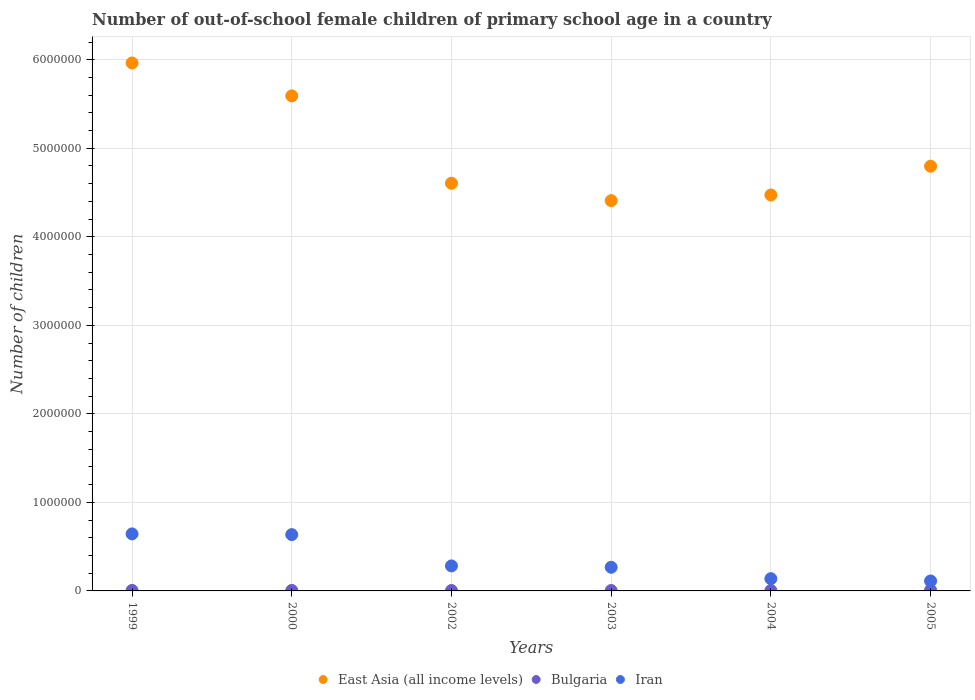How many different coloured dotlines are there?
Your response must be concise. 3. What is the number of out-of-school female children in East Asia (all income levels) in 2005?
Ensure brevity in your answer.  4.80e+06. Across all years, what is the maximum number of out-of-school female children in East Asia (all income levels)?
Offer a terse response. 5.96e+06. Across all years, what is the minimum number of out-of-school female children in Iran?
Your response must be concise. 1.12e+05. In which year was the number of out-of-school female children in Bulgaria maximum?
Make the answer very short. 2005. In which year was the number of out-of-school female children in Bulgaria minimum?
Your response must be concise. 2003. What is the total number of out-of-school female children in Iran in the graph?
Keep it short and to the point. 2.08e+06. What is the difference between the number of out-of-school female children in Iran in 2000 and that in 2005?
Your answer should be very brief. 5.24e+05. What is the difference between the number of out-of-school female children in East Asia (all income levels) in 2004 and the number of out-of-school female children in Bulgaria in 2005?
Your answer should be very brief. 4.46e+06. What is the average number of out-of-school female children in East Asia (all income levels) per year?
Keep it short and to the point. 4.97e+06. In the year 2004, what is the difference between the number of out-of-school female children in Bulgaria and number of out-of-school female children in Iran?
Provide a short and direct response. -1.34e+05. What is the ratio of the number of out-of-school female children in East Asia (all income levels) in 2000 to that in 2004?
Provide a short and direct response. 1.25. Is the difference between the number of out-of-school female children in Bulgaria in 1999 and 2003 greater than the difference between the number of out-of-school female children in Iran in 1999 and 2003?
Ensure brevity in your answer.  No. What is the difference between the highest and the second highest number of out-of-school female children in East Asia (all income levels)?
Your response must be concise. 3.72e+05. What is the difference between the highest and the lowest number of out-of-school female children in East Asia (all income levels)?
Your answer should be compact. 1.56e+06. In how many years, is the number of out-of-school female children in Bulgaria greater than the average number of out-of-school female children in Bulgaria taken over all years?
Make the answer very short. 1. Is it the case that in every year, the sum of the number of out-of-school female children in Iran and number of out-of-school female children in Bulgaria  is greater than the number of out-of-school female children in East Asia (all income levels)?
Your answer should be compact. No. Is the number of out-of-school female children in East Asia (all income levels) strictly less than the number of out-of-school female children in Bulgaria over the years?
Your answer should be compact. No. How many dotlines are there?
Offer a very short reply. 3. How many years are there in the graph?
Make the answer very short. 6. Does the graph contain grids?
Keep it short and to the point. Yes. Where does the legend appear in the graph?
Your answer should be compact. Bottom center. How many legend labels are there?
Your answer should be very brief. 3. How are the legend labels stacked?
Keep it short and to the point. Horizontal. What is the title of the graph?
Your response must be concise. Number of out-of-school female children of primary school age in a country. What is the label or title of the X-axis?
Keep it short and to the point. Years. What is the label or title of the Y-axis?
Your answer should be very brief. Number of children. What is the Number of children in East Asia (all income levels) in 1999?
Your answer should be compact. 5.96e+06. What is the Number of children in Bulgaria in 1999?
Provide a succinct answer. 5332. What is the Number of children of Iran in 1999?
Offer a very short reply. 6.44e+05. What is the Number of children of East Asia (all income levels) in 2000?
Give a very brief answer. 5.59e+06. What is the Number of children in Bulgaria in 2000?
Provide a succinct answer. 5362. What is the Number of children of Iran in 2000?
Your answer should be compact. 6.36e+05. What is the Number of children of East Asia (all income levels) in 2002?
Offer a terse response. 4.61e+06. What is the Number of children of Bulgaria in 2002?
Provide a short and direct response. 4759. What is the Number of children in Iran in 2002?
Offer a very short reply. 2.83e+05. What is the Number of children of East Asia (all income levels) in 2003?
Your response must be concise. 4.41e+06. What is the Number of children of Bulgaria in 2003?
Your answer should be very brief. 4347. What is the Number of children in Iran in 2003?
Provide a short and direct response. 2.67e+05. What is the Number of children in East Asia (all income levels) in 2004?
Your response must be concise. 4.47e+06. What is the Number of children in Bulgaria in 2004?
Keep it short and to the point. 4721. What is the Number of children of Iran in 2004?
Your response must be concise. 1.38e+05. What is the Number of children in East Asia (all income levels) in 2005?
Offer a terse response. 4.80e+06. What is the Number of children of Bulgaria in 2005?
Your response must be concise. 8739. What is the Number of children of Iran in 2005?
Your response must be concise. 1.12e+05. Across all years, what is the maximum Number of children in East Asia (all income levels)?
Your response must be concise. 5.96e+06. Across all years, what is the maximum Number of children of Bulgaria?
Offer a very short reply. 8739. Across all years, what is the maximum Number of children of Iran?
Provide a short and direct response. 6.44e+05. Across all years, what is the minimum Number of children of East Asia (all income levels)?
Give a very brief answer. 4.41e+06. Across all years, what is the minimum Number of children of Bulgaria?
Your response must be concise. 4347. Across all years, what is the minimum Number of children in Iran?
Offer a terse response. 1.12e+05. What is the total Number of children in East Asia (all income levels) in the graph?
Give a very brief answer. 2.98e+07. What is the total Number of children in Bulgaria in the graph?
Provide a short and direct response. 3.33e+04. What is the total Number of children in Iran in the graph?
Ensure brevity in your answer.  2.08e+06. What is the difference between the Number of children in East Asia (all income levels) in 1999 and that in 2000?
Your response must be concise. 3.72e+05. What is the difference between the Number of children of Bulgaria in 1999 and that in 2000?
Offer a very short reply. -30. What is the difference between the Number of children of Iran in 1999 and that in 2000?
Your answer should be compact. 8106. What is the difference between the Number of children in East Asia (all income levels) in 1999 and that in 2002?
Ensure brevity in your answer.  1.36e+06. What is the difference between the Number of children in Bulgaria in 1999 and that in 2002?
Provide a short and direct response. 573. What is the difference between the Number of children in Iran in 1999 and that in 2002?
Ensure brevity in your answer.  3.62e+05. What is the difference between the Number of children in East Asia (all income levels) in 1999 and that in 2003?
Keep it short and to the point. 1.56e+06. What is the difference between the Number of children of Bulgaria in 1999 and that in 2003?
Make the answer very short. 985. What is the difference between the Number of children in Iran in 1999 and that in 2003?
Make the answer very short. 3.77e+05. What is the difference between the Number of children of East Asia (all income levels) in 1999 and that in 2004?
Make the answer very short. 1.49e+06. What is the difference between the Number of children of Bulgaria in 1999 and that in 2004?
Your response must be concise. 611. What is the difference between the Number of children in Iran in 1999 and that in 2004?
Provide a short and direct response. 5.06e+05. What is the difference between the Number of children of East Asia (all income levels) in 1999 and that in 2005?
Offer a terse response. 1.17e+06. What is the difference between the Number of children of Bulgaria in 1999 and that in 2005?
Keep it short and to the point. -3407. What is the difference between the Number of children of Iran in 1999 and that in 2005?
Your answer should be compact. 5.32e+05. What is the difference between the Number of children of East Asia (all income levels) in 2000 and that in 2002?
Provide a short and direct response. 9.87e+05. What is the difference between the Number of children of Bulgaria in 2000 and that in 2002?
Give a very brief answer. 603. What is the difference between the Number of children in Iran in 2000 and that in 2002?
Your response must be concise. 3.53e+05. What is the difference between the Number of children in East Asia (all income levels) in 2000 and that in 2003?
Provide a succinct answer. 1.18e+06. What is the difference between the Number of children of Bulgaria in 2000 and that in 2003?
Offer a very short reply. 1015. What is the difference between the Number of children of Iran in 2000 and that in 2003?
Your response must be concise. 3.69e+05. What is the difference between the Number of children in East Asia (all income levels) in 2000 and that in 2004?
Give a very brief answer. 1.12e+06. What is the difference between the Number of children of Bulgaria in 2000 and that in 2004?
Keep it short and to the point. 641. What is the difference between the Number of children in Iran in 2000 and that in 2004?
Your answer should be compact. 4.98e+05. What is the difference between the Number of children of East Asia (all income levels) in 2000 and that in 2005?
Make the answer very short. 7.94e+05. What is the difference between the Number of children in Bulgaria in 2000 and that in 2005?
Make the answer very short. -3377. What is the difference between the Number of children of Iran in 2000 and that in 2005?
Offer a terse response. 5.24e+05. What is the difference between the Number of children in East Asia (all income levels) in 2002 and that in 2003?
Keep it short and to the point. 1.97e+05. What is the difference between the Number of children in Bulgaria in 2002 and that in 2003?
Your response must be concise. 412. What is the difference between the Number of children in Iran in 2002 and that in 2003?
Your response must be concise. 1.54e+04. What is the difference between the Number of children of East Asia (all income levels) in 2002 and that in 2004?
Keep it short and to the point. 1.33e+05. What is the difference between the Number of children of Iran in 2002 and that in 2004?
Offer a terse response. 1.44e+05. What is the difference between the Number of children in East Asia (all income levels) in 2002 and that in 2005?
Ensure brevity in your answer.  -1.92e+05. What is the difference between the Number of children of Bulgaria in 2002 and that in 2005?
Ensure brevity in your answer.  -3980. What is the difference between the Number of children in Iran in 2002 and that in 2005?
Your answer should be compact. 1.70e+05. What is the difference between the Number of children of East Asia (all income levels) in 2003 and that in 2004?
Your answer should be very brief. -6.36e+04. What is the difference between the Number of children of Bulgaria in 2003 and that in 2004?
Your answer should be very brief. -374. What is the difference between the Number of children in Iran in 2003 and that in 2004?
Provide a short and direct response. 1.29e+05. What is the difference between the Number of children in East Asia (all income levels) in 2003 and that in 2005?
Offer a very short reply. -3.89e+05. What is the difference between the Number of children of Bulgaria in 2003 and that in 2005?
Offer a very short reply. -4392. What is the difference between the Number of children of Iran in 2003 and that in 2005?
Keep it short and to the point. 1.55e+05. What is the difference between the Number of children in East Asia (all income levels) in 2004 and that in 2005?
Ensure brevity in your answer.  -3.25e+05. What is the difference between the Number of children in Bulgaria in 2004 and that in 2005?
Offer a very short reply. -4018. What is the difference between the Number of children of Iran in 2004 and that in 2005?
Give a very brief answer. 2.59e+04. What is the difference between the Number of children of East Asia (all income levels) in 1999 and the Number of children of Bulgaria in 2000?
Provide a succinct answer. 5.96e+06. What is the difference between the Number of children in East Asia (all income levels) in 1999 and the Number of children in Iran in 2000?
Your response must be concise. 5.33e+06. What is the difference between the Number of children of Bulgaria in 1999 and the Number of children of Iran in 2000?
Provide a succinct answer. -6.31e+05. What is the difference between the Number of children of East Asia (all income levels) in 1999 and the Number of children of Bulgaria in 2002?
Offer a very short reply. 5.96e+06. What is the difference between the Number of children in East Asia (all income levels) in 1999 and the Number of children in Iran in 2002?
Your answer should be compact. 5.68e+06. What is the difference between the Number of children in Bulgaria in 1999 and the Number of children in Iran in 2002?
Ensure brevity in your answer.  -2.77e+05. What is the difference between the Number of children in East Asia (all income levels) in 1999 and the Number of children in Bulgaria in 2003?
Offer a very short reply. 5.96e+06. What is the difference between the Number of children in East Asia (all income levels) in 1999 and the Number of children in Iran in 2003?
Your answer should be very brief. 5.70e+06. What is the difference between the Number of children of Bulgaria in 1999 and the Number of children of Iran in 2003?
Give a very brief answer. -2.62e+05. What is the difference between the Number of children in East Asia (all income levels) in 1999 and the Number of children in Bulgaria in 2004?
Give a very brief answer. 5.96e+06. What is the difference between the Number of children in East Asia (all income levels) in 1999 and the Number of children in Iran in 2004?
Your answer should be compact. 5.83e+06. What is the difference between the Number of children of Bulgaria in 1999 and the Number of children of Iran in 2004?
Your response must be concise. -1.33e+05. What is the difference between the Number of children of East Asia (all income levels) in 1999 and the Number of children of Bulgaria in 2005?
Offer a terse response. 5.95e+06. What is the difference between the Number of children of East Asia (all income levels) in 1999 and the Number of children of Iran in 2005?
Provide a succinct answer. 5.85e+06. What is the difference between the Number of children in Bulgaria in 1999 and the Number of children in Iran in 2005?
Provide a succinct answer. -1.07e+05. What is the difference between the Number of children in East Asia (all income levels) in 2000 and the Number of children in Bulgaria in 2002?
Your answer should be very brief. 5.59e+06. What is the difference between the Number of children of East Asia (all income levels) in 2000 and the Number of children of Iran in 2002?
Make the answer very short. 5.31e+06. What is the difference between the Number of children in Bulgaria in 2000 and the Number of children in Iran in 2002?
Your answer should be compact. -2.77e+05. What is the difference between the Number of children of East Asia (all income levels) in 2000 and the Number of children of Bulgaria in 2003?
Provide a succinct answer. 5.59e+06. What is the difference between the Number of children in East Asia (all income levels) in 2000 and the Number of children in Iran in 2003?
Your response must be concise. 5.32e+06. What is the difference between the Number of children in Bulgaria in 2000 and the Number of children in Iran in 2003?
Your answer should be very brief. -2.62e+05. What is the difference between the Number of children in East Asia (all income levels) in 2000 and the Number of children in Bulgaria in 2004?
Provide a succinct answer. 5.59e+06. What is the difference between the Number of children in East Asia (all income levels) in 2000 and the Number of children in Iran in 2004?
Make the answer very short. 5.45e+06. What is the difference between the Number of children in Bulgaria in 2000 and the Number of children in Iran in 2004?
Make the answer very short. -1.33e+05. What is the difference between the Number of children in East Asia (all income levels) in 2000 and the Number of children in Bulgaria in 2005?
Your answer should be compact. 5.58e+06. What is the difference between the Number of children in East Asia (all income levels) in 2000 and the Number of children in Iran in 2005?
Give a very brief answer. 5.48e+06. What is the difference between the Number of children in Bulgaria in 2000 and the Number of children in Iran in 2005?
Provide a succinct answer. -1.07e+05. What is the difference between the Number of children of East Asia (all income levels) in 2002 and the Number of children of Bulgaria in 2003?
Make the answer very short. 4.60e+06. What is the difference between the Number of children in East Asia (all income levels) in 2002 and the Number of children in Iran in 2003?
Offer a very short reply. 4.34e+06. What is the difference between the Number of children in Bulgaria in 2002 and the Number of children in Iran in 2003?
Keep it short and to the point. -2.62e+05. What is the difference between the Number of children in East Asia (all income levels) in 2002 and the Number of children in Bulgaria in 2004?
Keep it short and to the point. 4.60e+06. What is the difference between the Number of children of East Asia (all income levels) in 2002 and the Number of children of Iran in 2004?
Ensure brevity in your answer.  4.47e+06. What is the difference between the Number of children of Bulgaria in 2002 and the Number of children of Iran in 2004?
Offer a very short reply. -1.34e+05. What is the difference between the Number of children of East Asia (all income levels) in 2002 and the Number of children of Bulgaria in 2005?
Keep it short and to the point. 4.60e+06. What is the difference between the Number of children in East Asia (all income levels) in 2002 and the Number of children in Iran in 2005?
Keep it short and to the point. 4.49e+06. What is the difference between the Number of children of Bulgaria in 2002 and the Number of children of Iran in 2005?
Keep it short and to the point. -1.08e+05. What is the difference between the Number of children in East Asia (all income levels) in 2003 and the Number of children in Bulgaria in 2004?
Offer a terse response. 4.40e+06. What is the difference between the Number of children in East Asia (all income levels) in 2003 and the Number of children in Iran in 2004?
Make the answer very short. 4.27e+06. What is the difference between the Number of children of Bulgaria in 2003 and the Number of children of Iran in 2004?
Provide a short and direct response. -1.34e+05. What is the difference between the Number of children in East Asia (all income levels) in 2003 and the Number of children in Bulgaria in 2005?
Provide a succinct answer. 4.40e+06. What is the difference between the Number of children in East Asia (all income levels) in 2003 and the Number of children in Iran in 2005?
Keep it short and to the point. 4.30e+06. What is the difference between the Number of children of Bulgaria in 2003 and the Number of children of Iran in 2005?
Ensure brevity in your answer.  -1.08e+05. What is the difference between the Number of children of East Asia (all income levels) in 2004 and the Number of children of Bulgaria in 2005?
Offer a terse response. 4.46e+06. What is the difference between the Number of children of East Asia (all income levels) in 2004 and the Number of children of Iran in 2005?
Offer a very short reply. 4.36e+06. What is the difference between the Number of children in Bulgaria in 2004 and the Number of children in Iran in 2005?
Provide a short and direct response. -1.08e+05. What is the average Number of children of East Asia (all income levels) per year?
Offer a terse response. 4.97e+06. What is the average Number of children of Bulgaria per year?
Give a very brief answer. 5543.33. What is the average Number of children of Iran per year?
Provide a succinct answer. 3.47e+05. In the year 1999, what is the difference between the Number of children of East Asia (all income levels) and Number of children of Bulgaria?
Your answer should be compact. 5.96e+06. In the year 1999, what is the difference between the Number of children in East Asia (all income levels) and Number of children in Iran?
Make the answer very short. 5.32e+06. In the year 1999, what is the difference between the Number of children of Bulgaria and Number of children of Iran?
Your response must be concise. -6.39e+05. In the year 2000, what is the difference between the Number of children in East Asia (all income levels) and Number of children in Bulgaria?
Offer a terse response. 5.59e+06. In the year 2000, what is the difference between the Number of children of East Asia (all income levels) and Number of children of Iran?
Make the answer very short. 4.96e+06. In the year 2000, what is the difference between the Number of children of Bulgaria and Number of children of Iran?
Provide a succinct answer. -6.31e+05. In the year 2002, what is the difference between the Number of children of East Asia (all income levels) and Number of children of Bulgaria?
Offer a terse response. 4.60e+06. In the year 2002, what is the difference between the Number of children of East Asia (all income levels) and Number of children of Iran?
Your answer should be very brief. 4.32e+06. In the year 2002, what is the difference between the Number of children in Bulgaria and Number of children in Iran?
Provide a short and direct response. -2.78e+05. In the year 2003, what is the difference between the Number of children of East Asia (all income levels) and Number of children of Bulgaria?
Give a very brief answer. 4.40e+06. In the year 2003, what is the difference between the Number of children of East Asia (all income levels) and Number of children of Iran?
Offer a terse response. 4.14e+06. In the year 2003, what is the difference between the Number of children in Bulgaria and Number of children in Iran?
Give a very brief answer. -2.63e+05. In the year 2004, what is the difference between the Number of children of East Asia (all income levels) and Number of children of Bulgaria?
Your answer should be very brief. 4.47e+06. In the year 2004, what is the difference between the Number of children of East Asia (all income levels) and Number of children of Iran?
Provide a succinct answer. 4.33e+06. In the year 2004, what is the difference between the Number of children of Bulgaria and Number of children of Iran?
Provide a succinct answer. -1.34e+05. In the year 2005, what is the difference between the Number of children of East Asia (all income levels) and Number of children of Bulgaria?
Keep it short and to the point. 4.79e+06. In the year 2005, what is the difference between the Number of children in East Asia (all income levels) and Number of children in Iran?
Provide a short and direct response. 4.69e+06. In the year 2005, what is the difference between the Number of children of Bulgaria and Number of children of Iran?
Provide a short and direct response. -1.04e+05. What is the ratio of the Number of children of East Asia (all income levels) in 1999 to that in 2000?
Offer a very short reply. 1.07. What is the ratio of the Number of children of Bulgaria in 1999 to that in 2000?
Keep it short and to the point. 0.99. What is the ratio of the Number of children of Iran in 1999 to that in 2000?
Make the answer very short. 1.01. What is the ratio of the Number of children in East Asia (all income levels) in 1999 to that in 2002?
Your answer should be very brief. 1.29. What is the ratio of the Number of children in Bulgaria in 1999 to that in 2002?
Offer a very short reply. 1.12. What is the ratio of the Number of children of Iran in 1999 to that in 2002?
Your answer should be compact. 2.28. What is the ratio of the Number of children of East Asia (all income levels) in 1999 to that in 2003?
Provide a succinct answer. 1.35. What is the ratio of the Number of children of Bulgaria in 1999 to that in 2003?
Offer a very short reply. 1.23. What is the ratio of the Number of children of Iran in 1999 to that in 2003?
Provide a succinct answer. 2.41. What is the ratio of the Number of children in East Asia (all income levels) in 1999 to that in 2004?
Offer a terse response. 1.33. What is the ratio of the Number of children of Bulgaria in 1999 to that in 2004?
Provide a short and direct response. 1.13. What is the ratio of the Number of children in Iran in 1999 to that in 2004?
Ensure brevity in your answer.  4.66. What is the ratio of the Number of children in East Asia (all income levels) in 1999 to that in 2005?
Provide a succinct answer. 1.24. What is the ratio of the Number of children of Bulgaria in 1999 to that in 2005?
Ensure brevity in your answer.  0.61. What is the ratio of the Number of children in Iran in 1999 to that in 2005?
Offer a terse response. 5.73. What is the ratio of the Number of children in East Asia (all income levels) in 2000 to that in 2002?
Offer a terse response. 1.21. What is the ratio of the Number of children in Bulgaria in 2000 to that in 2002?
Make the answer very short. 1.13. What is the ratio of the Number of children in Iran in 2000 to that in 2002?
Offer a terse response. 2.25. What is the ratio of the Number of children of East Asia (all income levels) in 2000 to that in 2003?
Your answer should be very brief. 1.27. What is the ratio of the Number of children of Bulgaria in 2000 to that in 2003?
Your response must be concise. 1.23. What is the ratio of the Number of children in Iran in 2000 to that in 2003?
Make the answer very short. 2.38. What is the ratio of the Number of children of East Asia (all income levels) in 2000 to that in 2004?
Provide a succinct answer. 1.25. What is the ratio of the Number of children in Bulgaria in 2000 to that in 2004?
Your answer should be compact. 1.14. What is the ratio of the Number of children of Iran in 2000 to that in 2004?
Offer a very short reply. 4.6. What is the ratio of the Number of children of East Asia (all income levels) in 2000 to that in 2005?
Keep it short and to the point. 1.17. What is the ratio of the Number of children in Bulgaria in 2000 to that in 2005?
Your answer should be compact. 0.61. What is the ratio of the Number of children in Iran in 2000 to that in 2005?
Offer a very short reply. 5.66. What is the ratio of the Number of children in East Asia (all income levels) in 2002 to that in 2003?
Ensure brevity in your answer.  1.04. What is the ratio of the Number of children of Bulgaria in 2002 to that in 2003?
Your answer should be compact. 1.09. What is the ratio of the Number of children in Iran in 2002 to that in 2003?
Provide a short and direct response. 1.06. What is the ratio of the Number of children in East Asia (all income levels) in 2002 to that in 2004?
Ensure brevity in your answer.  1.03. What is the ratio of the Number of children in Bulgaria in 2002 to that in 2004?
Offer a terse response. 1.01. What is the ratio of the Number of children in Iran in 2002 to that in 2004?
Your response must be concise. 2.04. What is the ratio of the Number of children in East Asia (all income levels) in 2002 to that in 2005?
Give a very brief answer. 0.96. What is the ratio of the Number of children of Bulgaria in 2002 to that in 2005?
Offer a very short reply. 0.54. What is the ratio of the Number of children of Iran in 2002 to that in 2005?
Ensure brevity in your answer.  2.51. What is the ratio of the Number of children of East Asia (all income levels) in 2003 to that in 2004?
Offer a terse response. 0.99. What is the ratio of the Number of children of Bulgaria in 2003 to that in 2004?
Provide a short and direct response. 0.92. What is the ratio of the Number of children in Iran in 2003 to that in 2004?
Ensure brevity in your answer.  1.93. What is the ratio of the Number of children of East Asia (all income levels) in 2003 to that in 2005?
Provide a short and direct response. 0.92. What is the ratio of the Number of children of Bulgaria in 2003 to that in 2005?
Give a very brief answer. 0.5. What is the ratio of the Number of children of Iran in 2003 to that in 2005?
Your answer should be compact. 2.38. What is the ratio of the Number of children in East Asia (all income levels) in 2004 to that in 2005?
Offer a very short reply. 0.93. What is the ratio of the Number of children of Bulgaria in 2004 to that in 2005?
Provide a short and direct response. 0.54. What is the ratio of the Number of children of Iran in 2004 to that in 2005?
Make the answer very short. 1.23. What is the difference between the highest and the second highest Number of children in East Asia (all income levels)?
Your response must be concise. 3.72e+05. What is the difference between the highest and the second highest Number of children in Bulgaria?
Provide a short and direct response. 3377. What is the difference between the highest and the second highest Number of children in Iran?
Make the answer very short. 8106. What is the difference between the highest and the lowest Number of children of East Asia (all income levels)?
Give a very brief answer. 1.56e+06. What is the difference between the highest and the lowest Number of children of Bulgaria?
Your answer should be compact. 4392. What is the difference between the highest and the lowest Number of children of Iran?
Provide a succinct answer. 5.32e+05. 